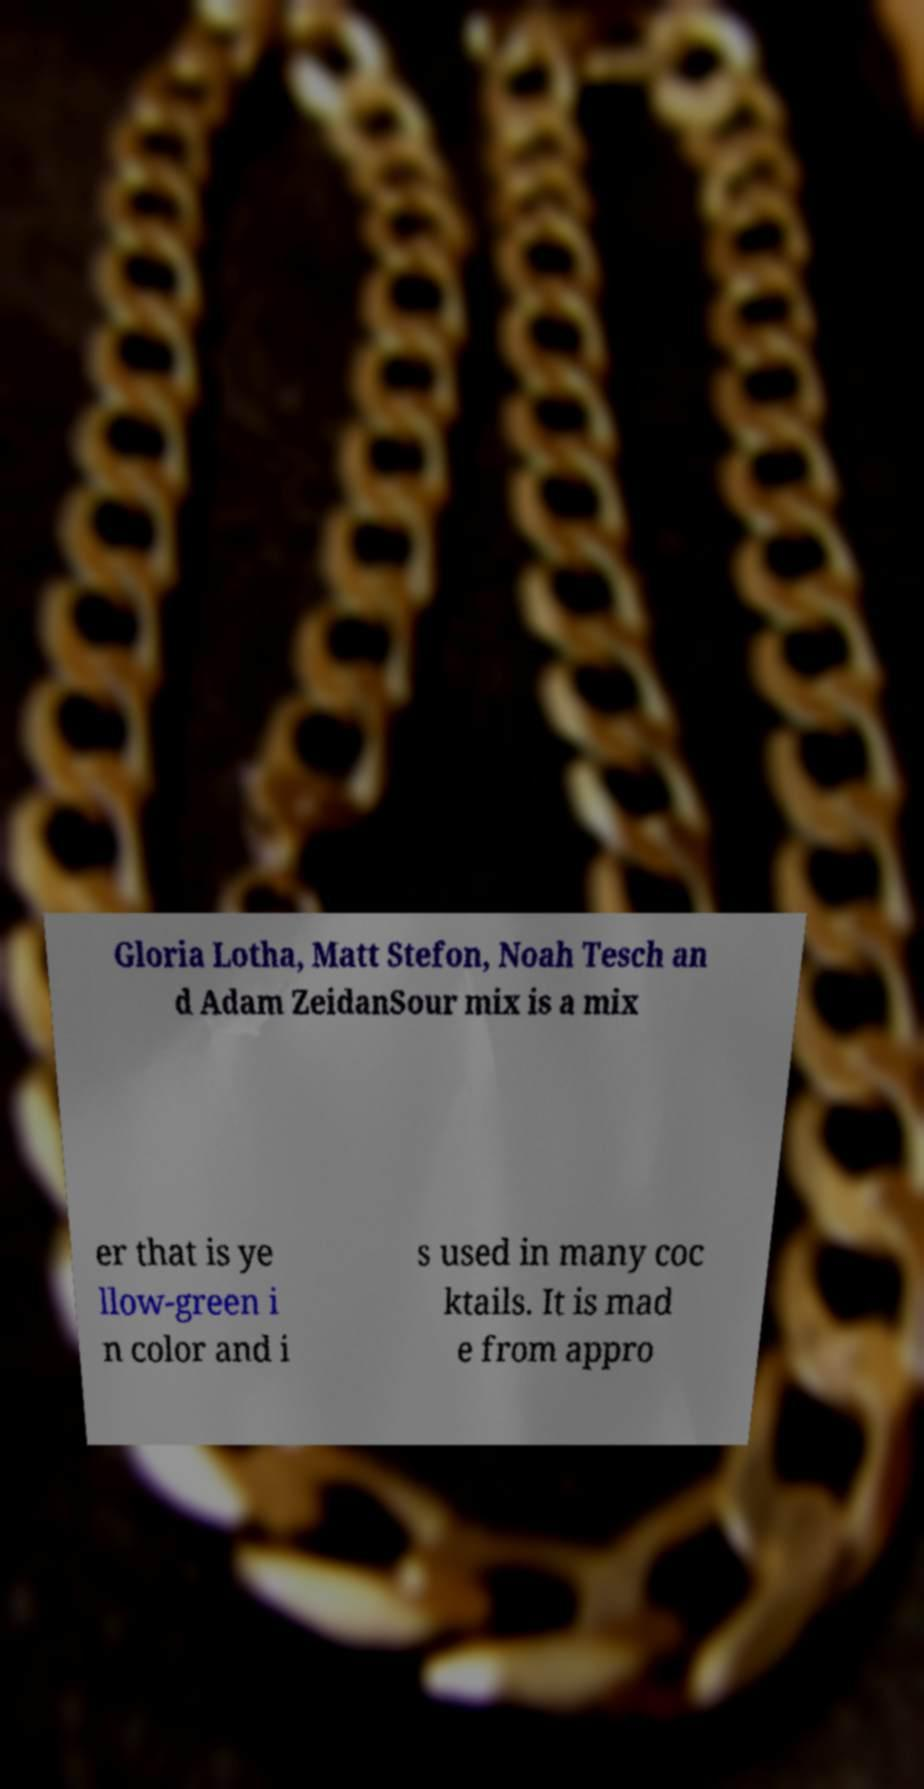Please identify and transcribe the text found in this image. Gloria Lotha, Matt Stefon, Noah Tesch an d Adam ZeidanSour mix is a mix er that is ye llow-green i n color and i s used in many coc ktails. It is mad e from appro 